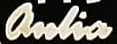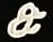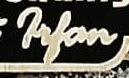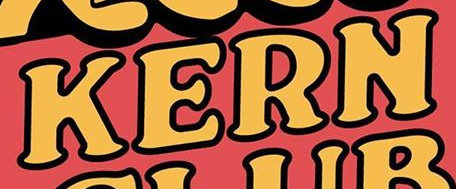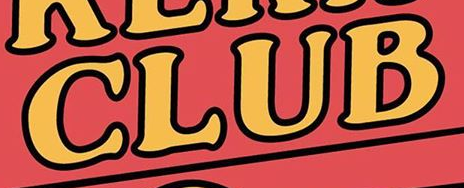What words are shown in these images in order, separated by a semicolon? anlia; &; Filan; KERN; CLUB 